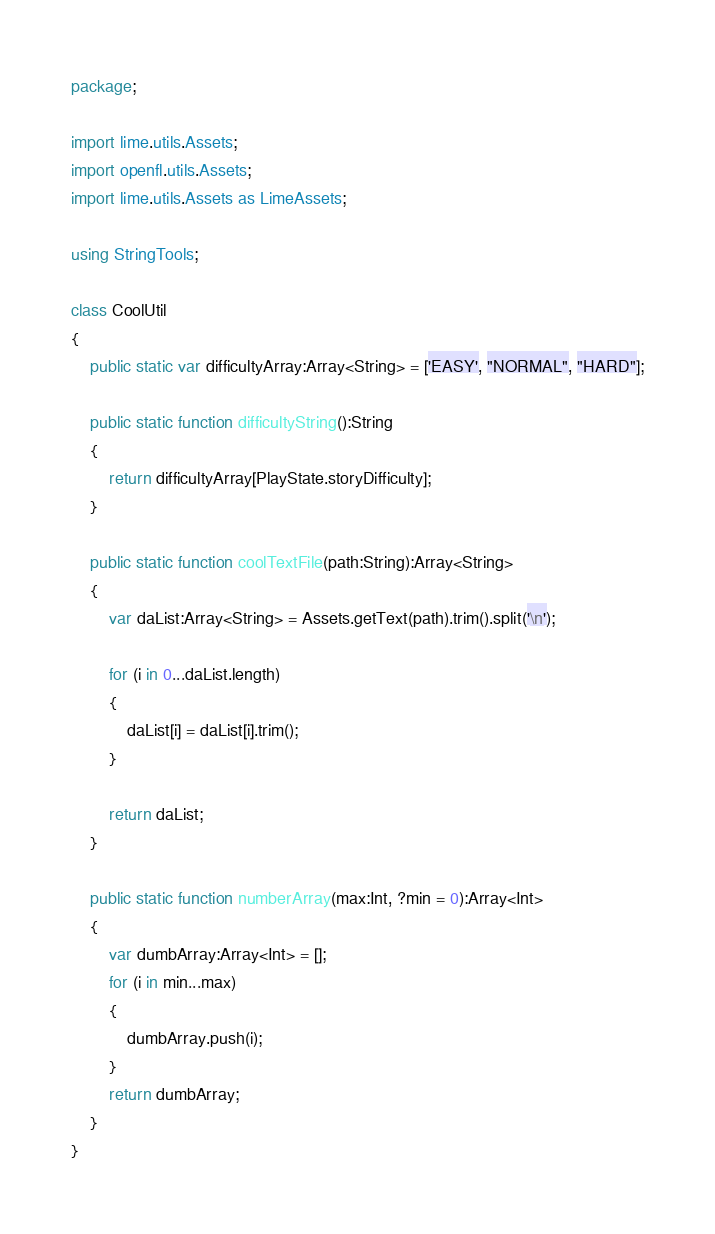<code> <loc_0><loc_0><loc_500><loc_500><_Haxe_>package;

import lime.utils.Assets;
import openfl.utils.Assets;
import lime.utils.Assets as LimeAssets;

using StringTools;

class CoolUtil
{
	public static var difficultyArray:Array<String> = ['EASY', "NORMAL", "HARD"];

	public static function difficultyString():String
	{
		return difficultyArray[PlayState.storyDifficulty];
	}

	public static function coolTextFile(path:String):Array<String>
	{
		var daList:Array<String> = Assets.getText(path).trim().split('\n');

		for (i in 0...daList.length)
		{
			daList[i] = daList[i].trim();
		}

		return daList;
	}

	public static function numberArray(max:Int, ?min = 0):Array<Int>
	{
		var dumbArray:Array<Int> = [];
		for (i in min...max)
		{
			dumbArray.push(i);
		}
		return dumbArray;
	}
}
</code> 